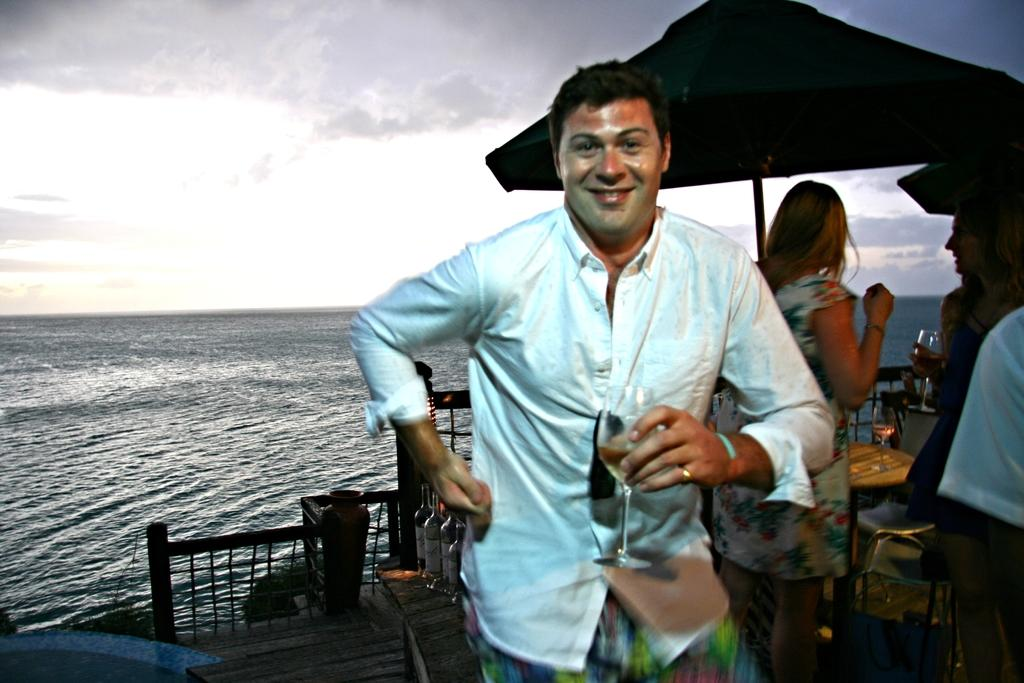What is the person in the image doing? The person is standing in the image and holding a glass in his hand. Can you describe the background of the image? There are other people, a tent, bottles, water, and the sky visible in the background of the image. How many people are present in the image? There is one person standing in the image, and there are other people visible in the background. What type of jewel is the person exchanging with the other person in the image? There is no exchange of jewels or any other items visible in the image. 